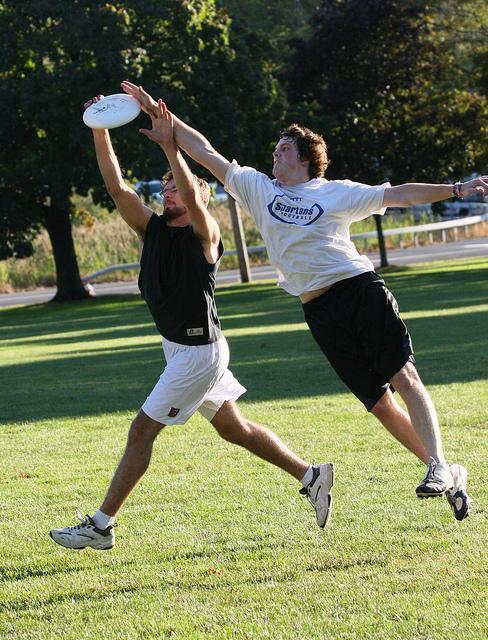The player wearing what color of shirt is likely to catch the frisbee?
Choose the right answer and clarify with the format: 'Answer: answer
Rationale: rationale.'
Options: White, brown, blue, black. Answer: black.
Rationale: The frisbee is in between the hands of the man on the left. 